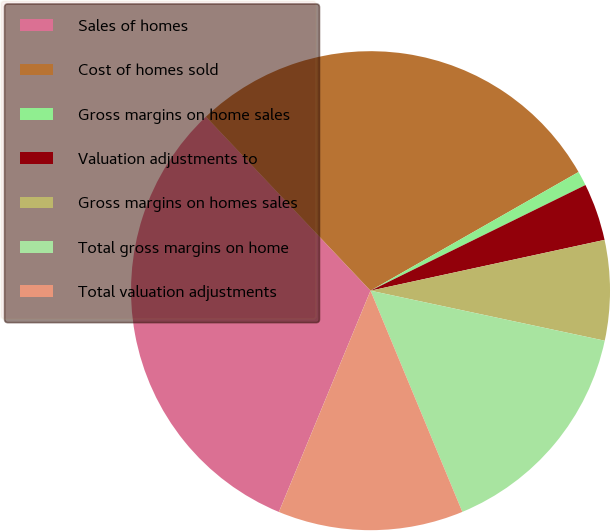<chart> <loc_0><loc_0><loc_500><loc_500><pie_chart><fcel>Sales of homes<fcel>Cost of homes sold<fcel>Gross margins on home sales<fcel>Valuation adjustments to<fcel>Gross margins on homes sales<fcel>Total gross margins on home<fcel>Total valuation adjustments<nl><fcel>31.69%<fcel>28.81%<fcel>0.98%<fcel>3.87%<fcel>6.75%<fcel>15.39%<fcel>12.51%<nl></chart> 